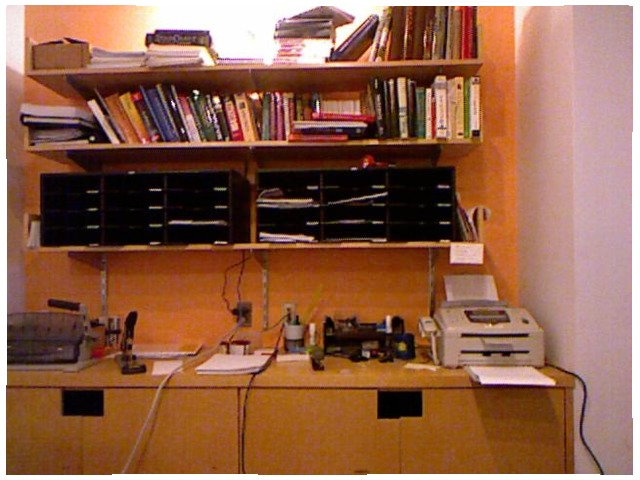<image>
Can you confirm if the printer is under the book self? Yes. The printer is positioned underneath the book self, with the book self above it in the vertical space. Is the book under the printer? No. The book is not positioned under the printer. The vertical relationship between these objects is different. Is the outlet to the right of the printer? Yes. From this viewpoint, the outlet is positioned to the right side relative to the printer. 